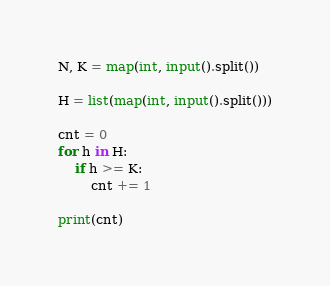Convert code to text. <code><loc_0><loc_0><loc_500><loc_500><_Python_>N, K = map(int, input().split())

H = list(map(int, input().split()))

cnt = 0
for h in H:
    if h >= K:
        cnt += 1

print(cnt)</code> 